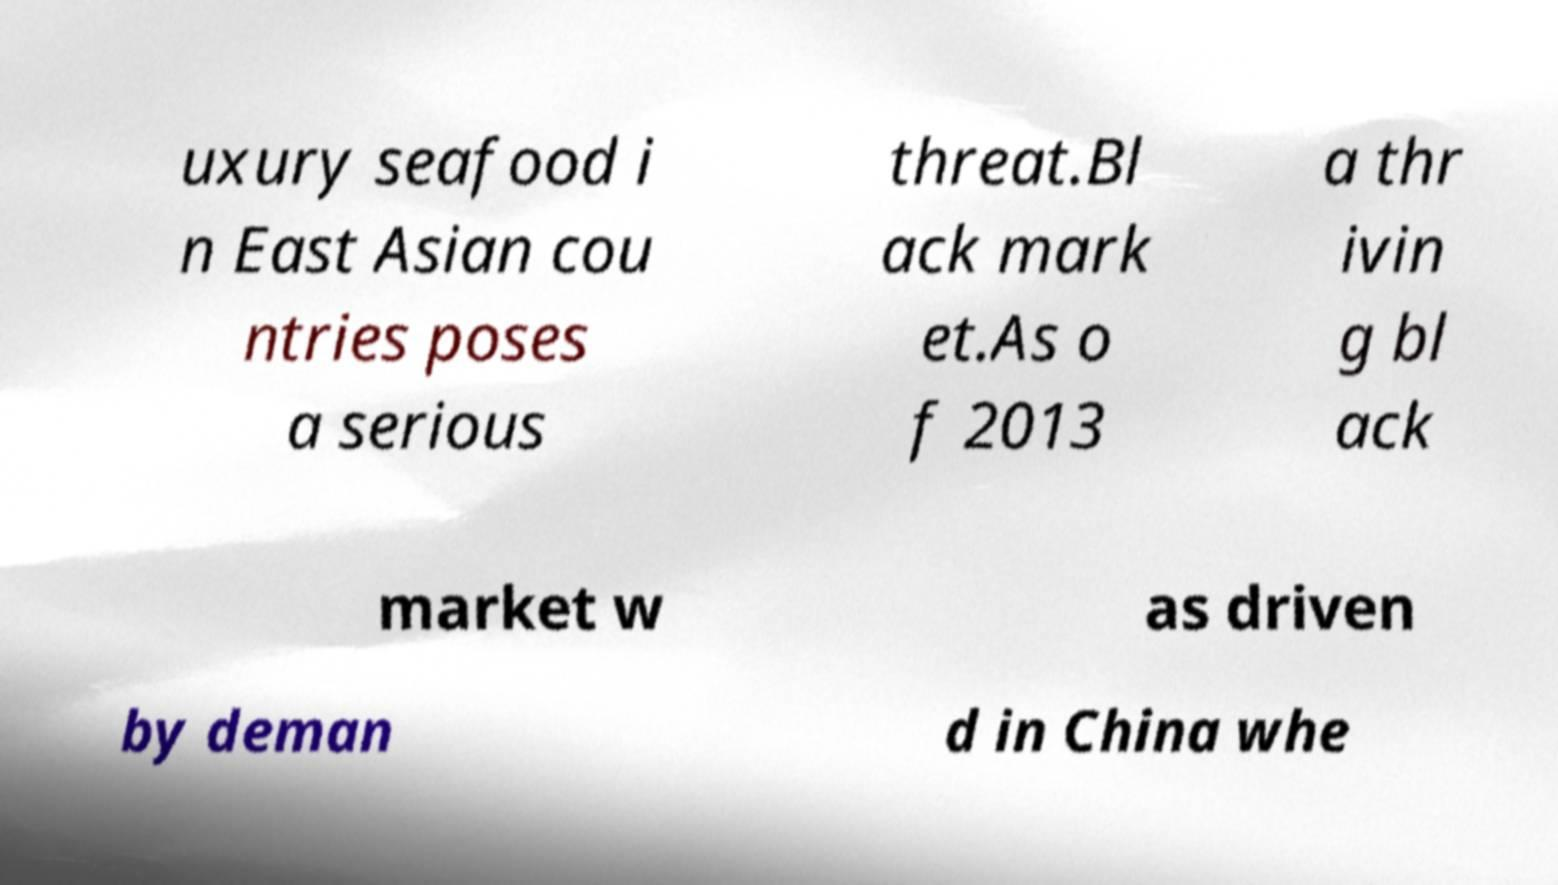Could you assist in decoding the text presented in this image and type it out clearly? uxury seafood i n East Asian cou ntries poses a serious threat.Bl ack mark et.As o f 2013 a thr ivin g bl ack market w as driven by deman d in China whe 